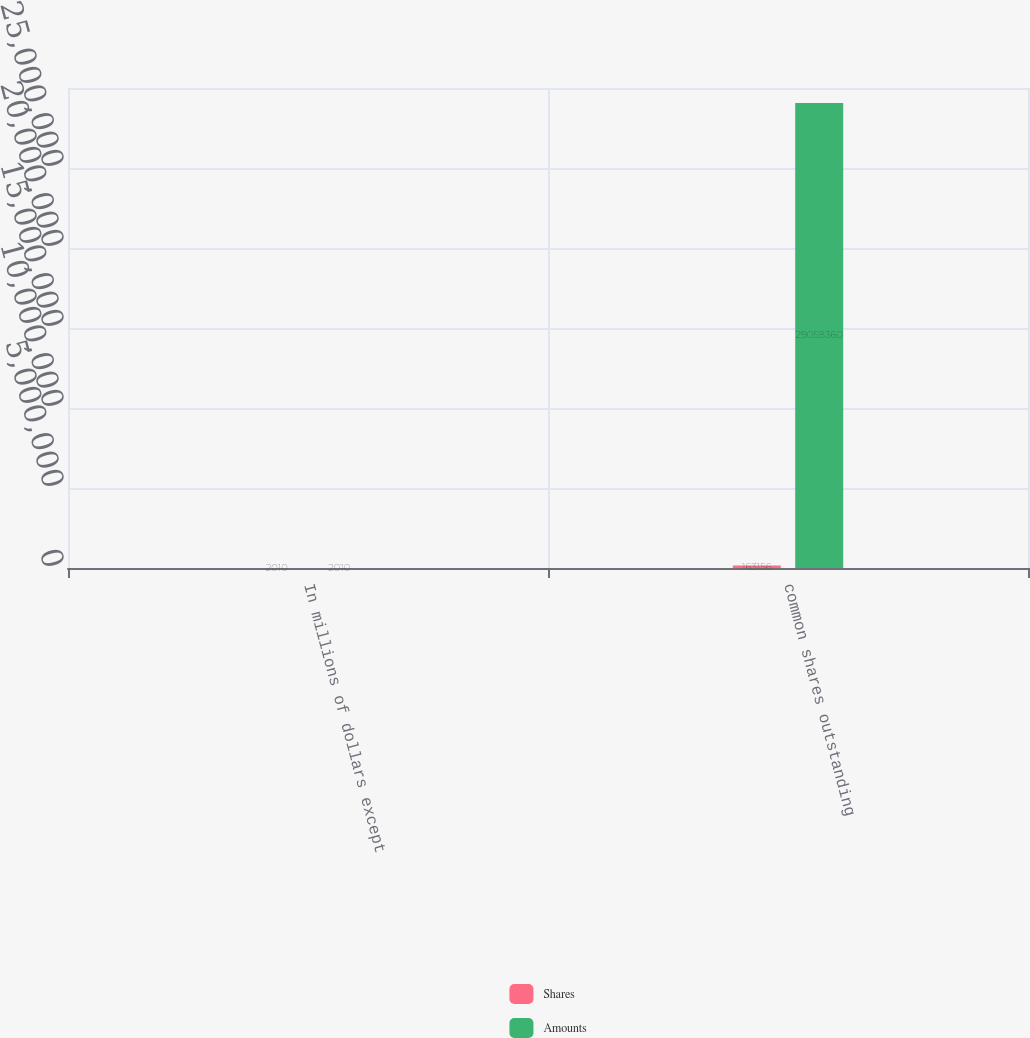Convert chart. <chart><loc_0><loc_0><loc_500><loc_500><stacked_bar_chart><ecel><fcel>In millions of dollars except<fcel>common shares outstanding<nl><fcel>Shares<fcel>2010<fcel>163156<nl><fcel>Amounts<fcel>2010<fcel>2.90584e+07<nl></chart> 